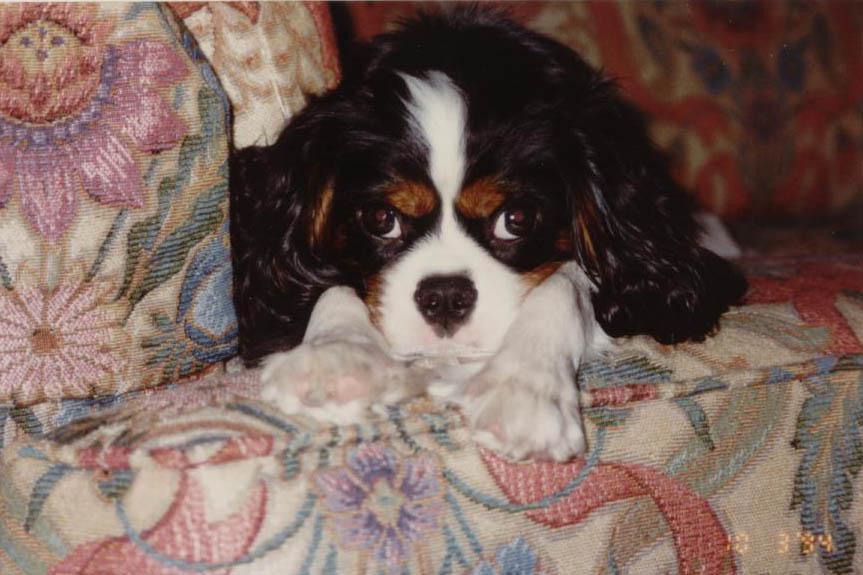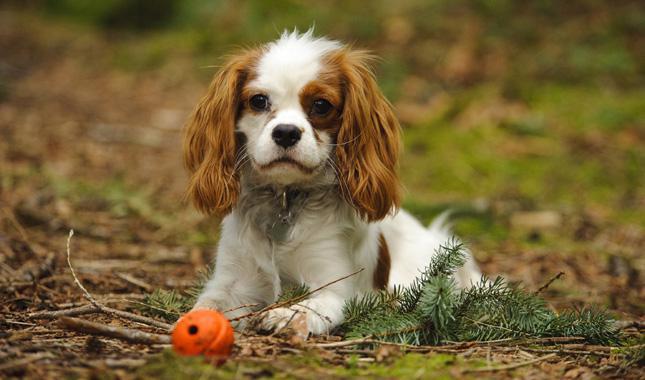The first image is the image on the left, the second image is the image on the right. Evaluate the accuracy of this statement regarding the images: "At least one of the dogs is sitting outside.". Is it true? Answer yes or no. Yes. The first image is the image on the left, the second image is the image on the right. For the images displayed, is the sentence "An image contains at least two dogs." factually correct? Answer yes or no. No. 